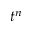Convert formula to latex. <formula><loc_0><loc_0><loc_500><loc_500>t ^ { n }</formula> 